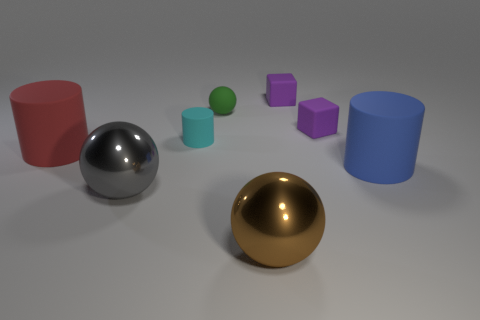What can you infer about the purpose of this image? This image seems to be a 3D rendering, possibly created to showcase computer graphics skills or to illustrate concepts in geometry. The carefully arranged shapes and the clean environment might indicate it was designed for educational purposes or as part of a visual arts project. 